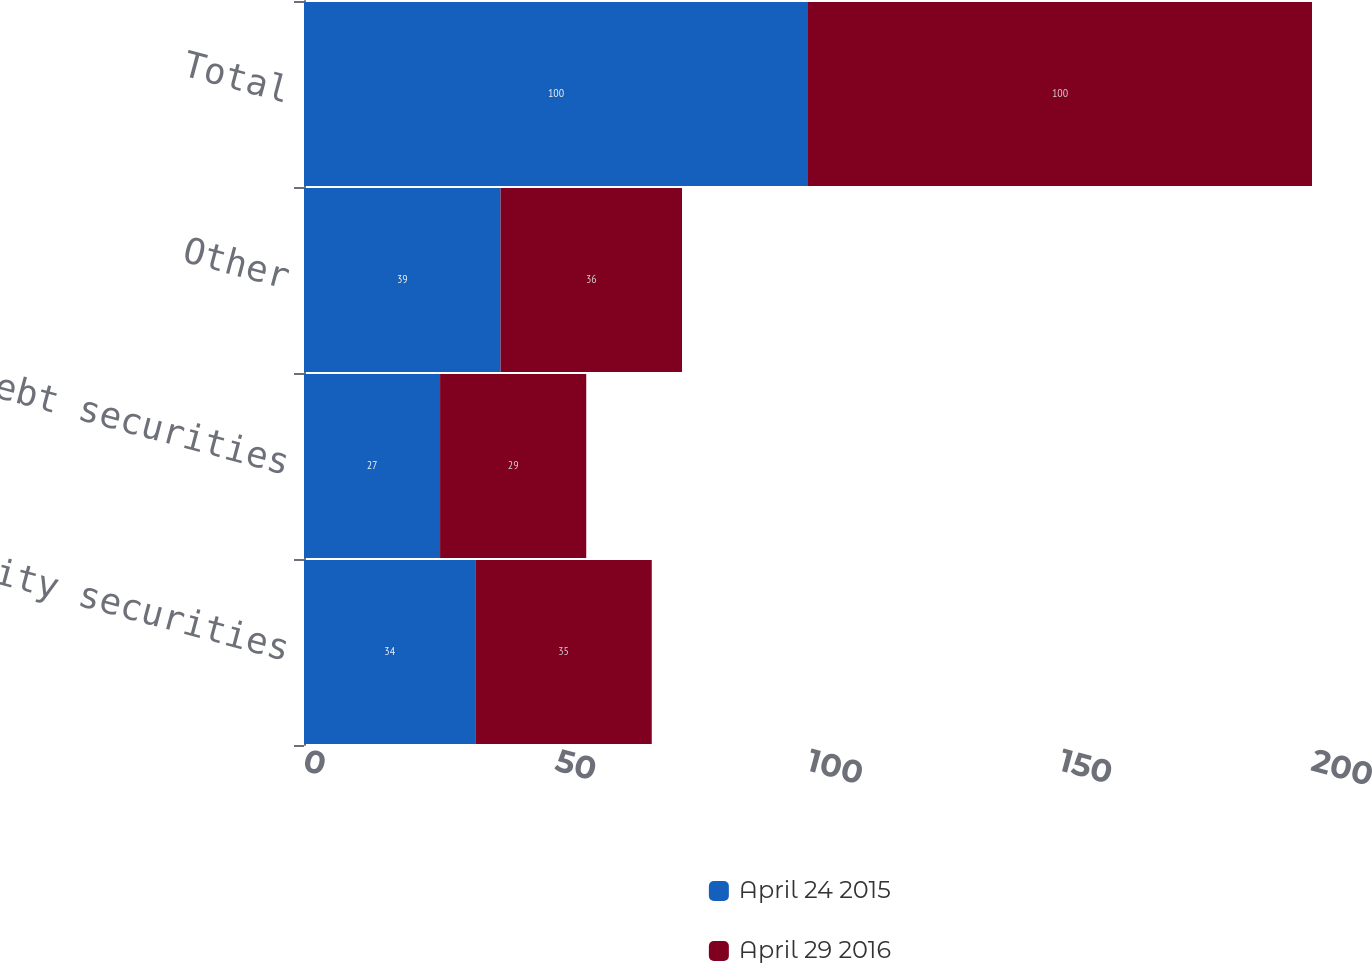Convert chart to OTSL. <chart><loc_0><loc_0><loc_500><loc_500><stacked_bar_chart><ecel><fcel>Equity securities<fcel>Debt securities<fcel>Other<fcel>Total<nl><fcel>April 24 2015<fcel>34<fcel>27<fcel>39<fcel>100<nl><fcel>April 29 2016<fcel>35<fcel>29<fcel>36<fcel>100<nl></chart> 